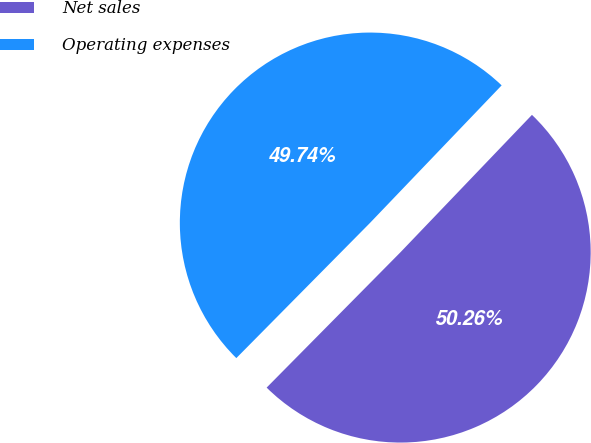Convert chart to OTSL. <chart><loc_0><loc_0><loc_500><loc_500><pie_chart><fcel>Net sales<fcel>Operating expenses<nl><fcel>50.26%<fcel>49.74%<nl></chart> 